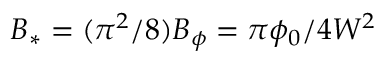Convert formula to latex. <formula><loc_0><loc_0><loc_500><loc_500>B _ { * } = ( \pi ^ { 2 } / 8 ) B _ { \phi } = \pi \phi _ { 0 } / 4 W ^ { 2 }</formula> 